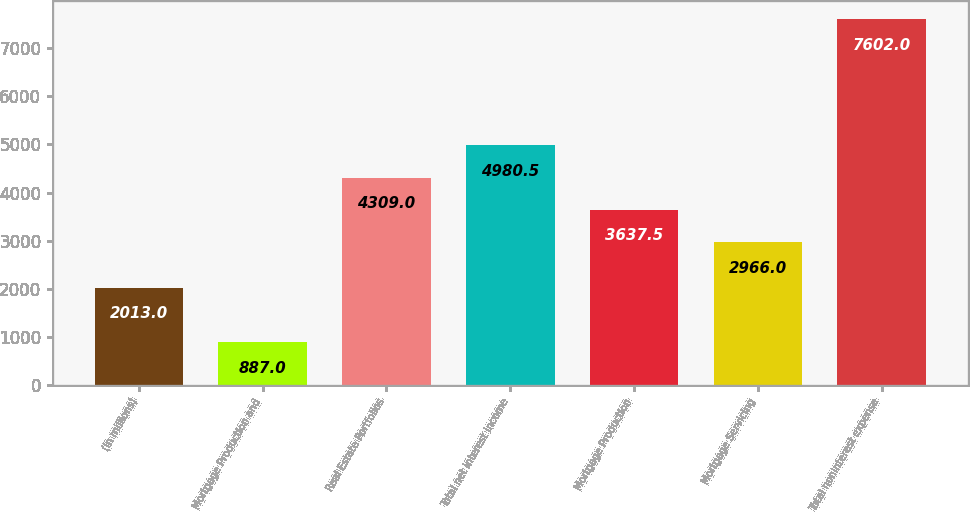Convert chart to OTSL. <chart><loc_0><loc_0><loc_500><loc_500><bar_chart><fcel>(in millions)<fcel>Mortgage Production and<fcel>Real Estate Portfolios<fcel>Total net interest income<fcel>Mortgage Production<fcel>Mortgage Servicing<fcel>Total noninterest expense<nl><fcel>2013<fcel>887<fcel>4309<fcel>4980.5<fcel>3637.5<fcel>2966<fcel>7602<nl></chart> 